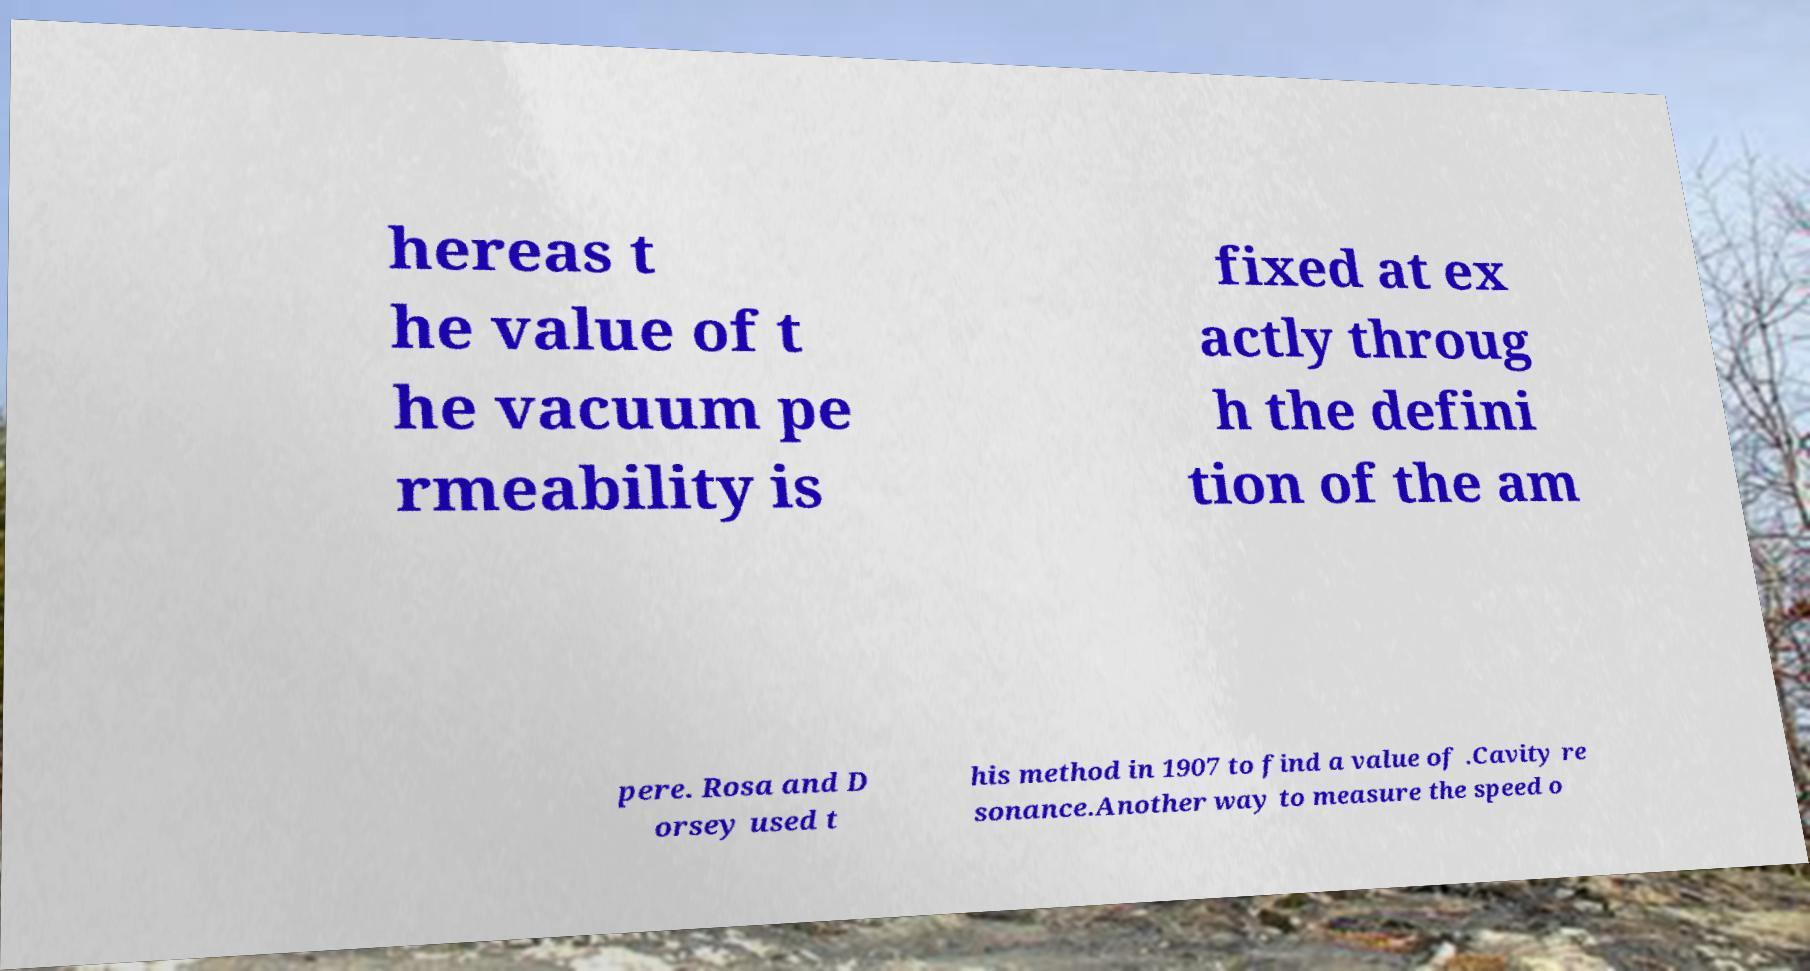Please read and relay the text visible in this image. What does it say? hereas t he value of t he vacuum pe rmeability is fixed at ex actly throug h the defini tion of the am pere. Rosa and D orsey used t his method in 1907 to find a value of .Cavity re sonance.Another way to measure the speed o 